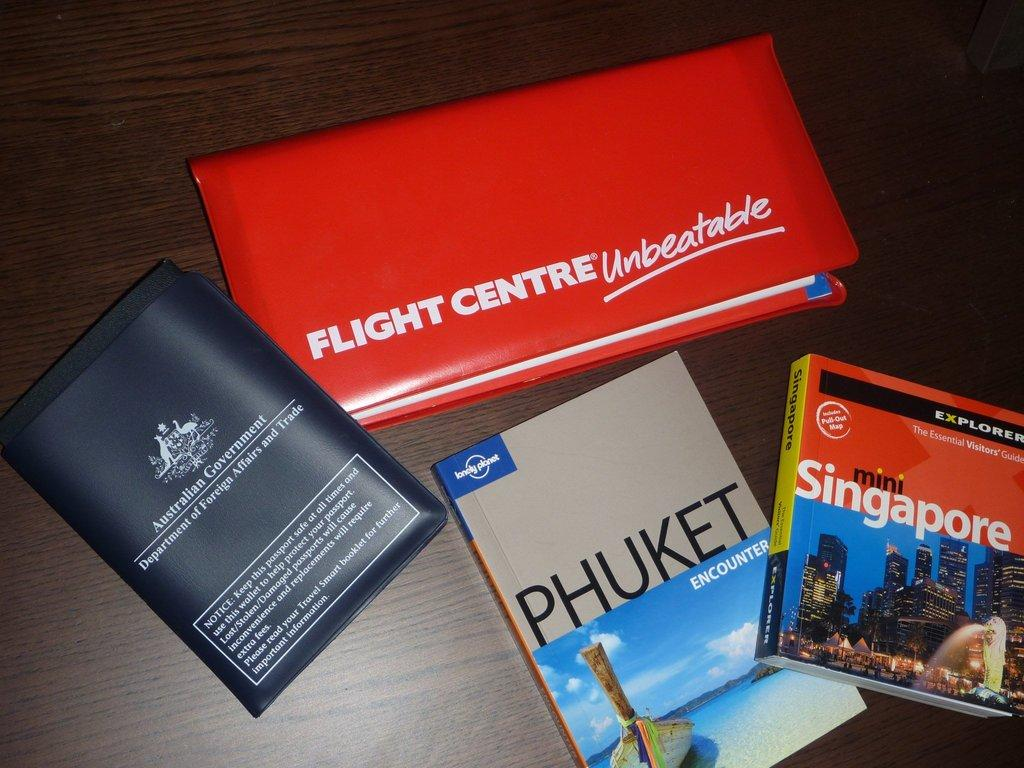<image>
Summarize the visual content of the image. travel books to Phuket and Singapore along with a passport and red notebook with writing on it 